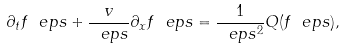<formula> <loc_0><loc_0><loc_500><loc_500>\partial _ { t } f _ { \ } e p s + \frac { v } { \ e p s } \partial _ { x } f _ { \ } e p s = \frac { 1 } { \ e p s ^ { 2 } } Q ( f _ { \ } e p s ) ,</formula> 